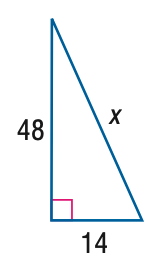Answer the mathemtical geometry problem and directly provide the correct option letter.
Question: Use a Pythagorean Triple to find x.
Choices: A: 50 B: 52 C: 54 D: 56 A 